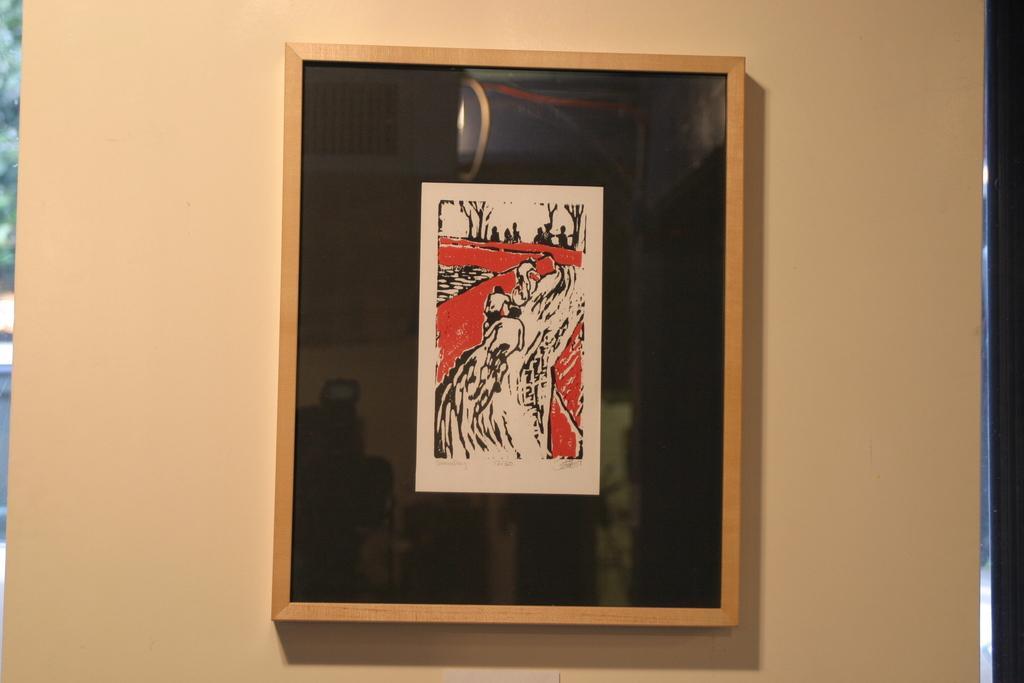In one or two sentences, can you explain what this image depicts? In this image I can see a sketch on a paper, three persons are riding the bicycles. 